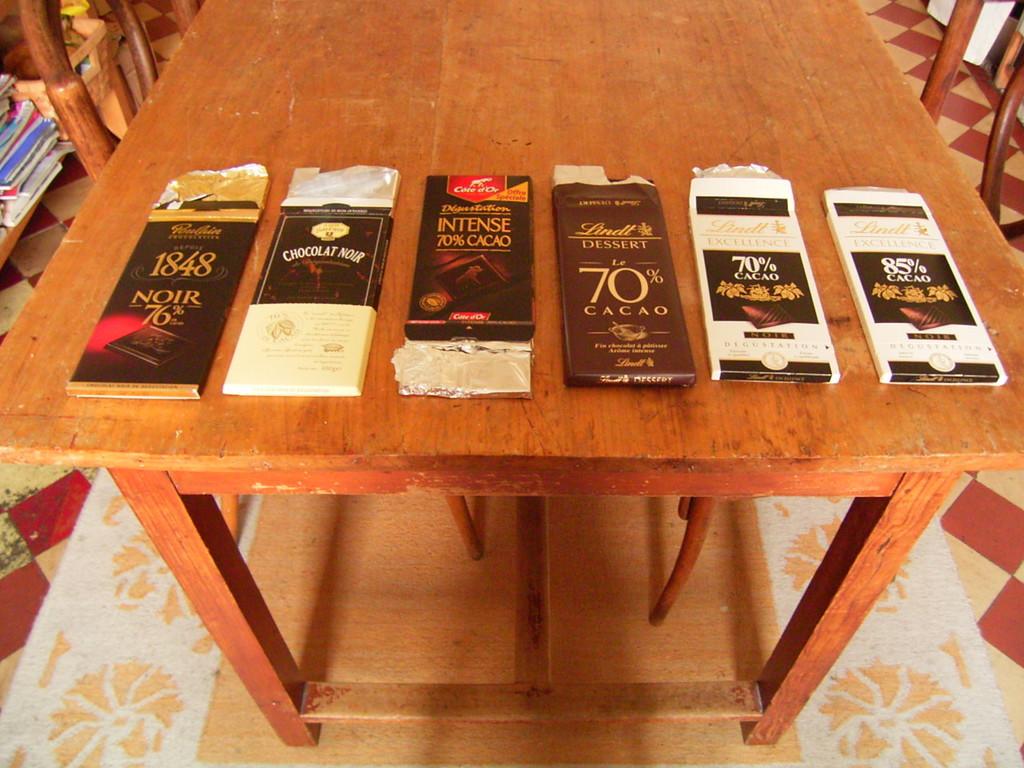What kind of candy is shown here?
Keep it short and to the point. Cacao. 5 variety of candy?
Your response must be concise. No. 